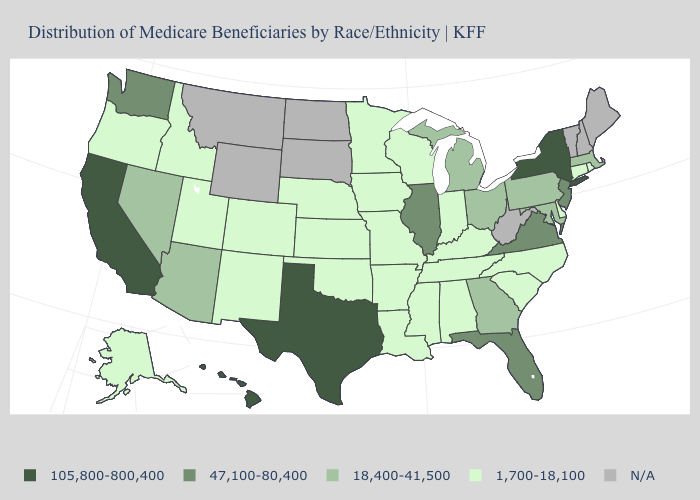Name the states that have a value in the range 18,400-41,500?
Concise answer only. Arizona, Georgia, Maryland, Massachusetts, Michigan, Nevada, Ohio, Pennsylvania. What is the value of New Jersey?
Concise answer only. 47,100-80,400. Name the states that have a value in the range 1,700-18,100?
Answer briefly. Alabama, Alaska, Arkansas, Colorado, Connecticut, Delaware, Idaho, Indiana, Iowa, Kansas, Kentucky, Louisiana, Minnesota, Mississippi, Missouri, Nebraska, New Mexico, North Carolina, Oklahoma, Oregon, Rhode Island, South Carolina, Tennessee, Utah, Wisconsin. Among the states that border Delaware , does New Jersey have the highest value?
Keep it brief. Yes. Which states have the lowest value in the USA?
Write a very short answer. Alabama, Alaska, Arkansas, Colorado, Connecticut, Delaware, Idaho, Indiana, Iowa, Kansas, Kentucky, Louisiana, Minnesota, Mississippi, Missouri, Nebraska, New Mexico, North Carolina, Oklahoma, Oregon, Rhode Island, South Carolina, Tennessee, Utah, Wisconsin. Name the states that have a value in the range N/A?
Concise answer only. Maine, Montana, New Hampshire, North Dakota, South Dakota, Vermont, West Virginia, Wyoming. What is the lowest value in the Northeast?
Write a very short answer. 1,700-18,100. Does the first symbol in the legend represent the smallest category?
Answer briefly. No. What is the highest value in the MidWest ?
Write a very short answer. 47,100-80,400. Does the first symbol in the legend represent the smallest category?
Be succinct. No. Among the states that border Georgia , which have the lowest value?
Give a very brief answer. Alabama, North Carolina, South Carolina, Tennessee. Which states have the highest value in the USA?
Be succinct. California, Hawaii, New York, Texas. Which states have the lowest value in the MidWest?
Short answer required. Indiana, Iowa, Kansas, Minnesota, Missouri, Nebraska, Wisconsin. Is the legend a continuous bar?
Give a very brief answer. No. 